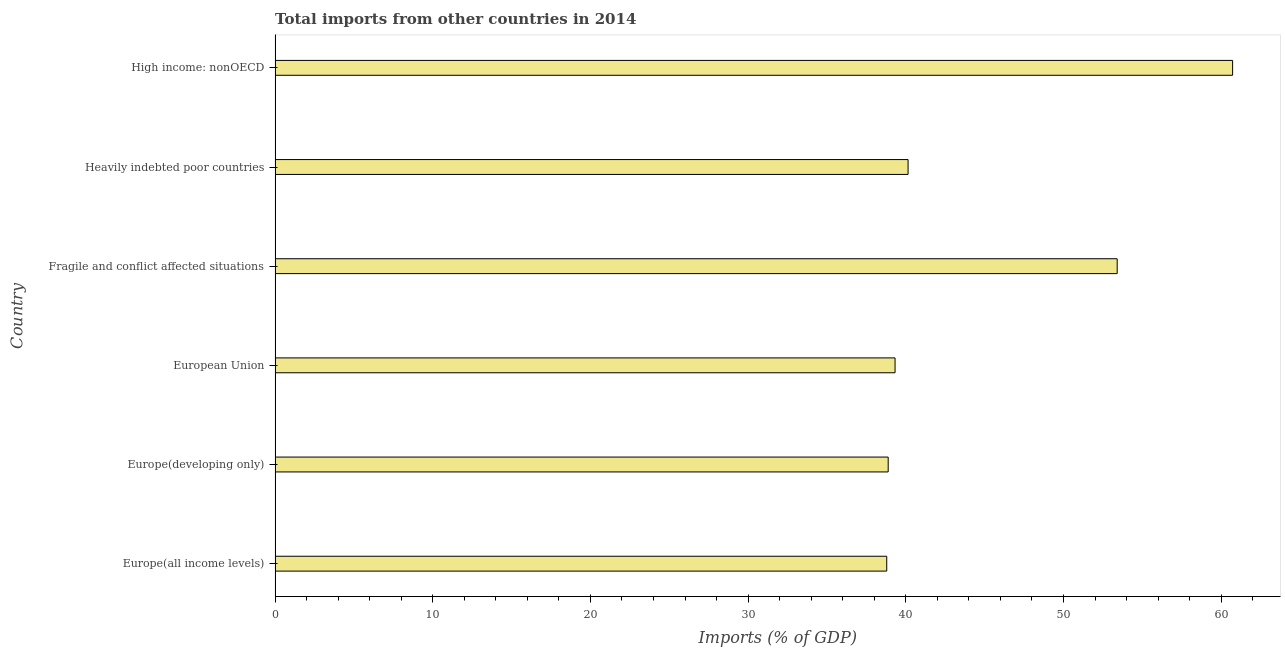Does the graph contain grids?
Offer a terse response. No. What is the title of the graph?
Ensure brevity in your answer.  Total imports from other countries in 2014. What is the label or title of the X-axis?
Provide a short and direct response. Imports (% of GDP). What is the label or title of the Y-axis?
Give a very brief answer. Country. What is the total imports in European Union?
Your response must be concise. 39.32. Across all countries, what is the maximum total imports?
Your answer should be compact. 60.73. Across all countries, what is the minimum total imports?
Give a very brief answer. 38.79. In which country was the total imports maximum?
Offer a very short reply. High income: nonOECD. In which country was the total imports minimum?
Your answer should be very brief. Europe(all income levels). What is the sum of the total imports?
Keep it short and to the point. 271.27. What is the difference between the total imports in Europe(developing only) and High income: nonOECD?
Give a very brief answer. -21.84. What is the average total imports per country?
Your response must be concise. 45.21. What is the median total imports?
Provide a succinct answer. 39.73. In how many countries, is the total imports greater than 16 %?
Keep it short and to the point. 6. Is the difference between the total imports in Europe(all income levels) and Fragile and conflict affected situations greater than the difference between any two countries?
Offer a very short reply. No. What is the difference between the highest and the second highest total imports?
Make the answer very short. 7.32. Is the sum of the total imports in Europe(developing only) and High income: nonOECD greater than the maximum total imports across all countries?
Keep it short and to the point. Yes. What is the difference between the highest and the lowest total imports?
Offer a very short reply. 21.94. In how many countries, is the total imports greater than the average total imports taken over all countries?
Your response must be concise. 2. How many bars are there?
Provide a succinct answer. 6. Are all the bars in the graph horizontal?
Your answer should be very brief. Yes. How many countries are there in the graph?
Make the answer very short. 6. What is the difference between two consecutive major ticks on the X-axis?
Ensure brevity in your answer.  10. What is the Imports (% of GDP) in Europe(all income levels)?
Give a very brief answer. 38.79. What is the Imports (% of GDP) of Europe(developing only)?
Your answer should be very brief. 38.88. What is the Imports (% of GDP) in European Union?
Ensure brevity in your answer.  39.32. What is the Imports (% of GDP) in Fragile and conflict affected situations?
Provide a succinct answer. 53.41. What is the Imports (% of GDP) of Heavily indebted poor countries?
Provide a short and direct response. 40.14. What is the Imports (% of GDP) in High income: nonOECD?
Keep it short and to the point. 60.73. What is the difference between the Imports (% of GDP) in Europe(all income levels) and Europe(developing only)?
Offer a terse response. -0.09. What is the difference between the Imports (% of GDP) in Europe(all income levels) and European Union?
Your response must be concise. -0.53. What is the difference between the Imports (% of GDP) in Europe(all income levels) and Fragile and conflict affected situations?
Provide a short and direct response. -14.62. What is the difference between the Imports (% of GDP) in Europe(all income levels) and Heavily indebted poor countries?
Offer a very short reply. -1.35. What is the difference between the Imports (% of GDP) in Europe(all income levels) and High income: nonOECD?
Give a very brief answer. -21.94. What is the difference between the Imports (% of GDP) in Europe(developing only) and European Union?
Offer a very short reply. -0.44. What is the difference between the Imports (% of GDP) in Europe(developing only) and Fragile and conflict affected situations?
Offer a terse response. -14.52. What is the difference between the Imports (% of GDP) in Europe(developing only) and Heavily indebted poor countries?
Your response must be concise. -1.26. What is the difference between the Imports (% of GDP) in Europe(developing only) and High income: nonOECD?
Your answer should be very brief. -21.84. What is the difference between the Imports (% of GDP) in European Union and Fragile and conflict affected situations?
Offer a terse response. -14.09. What is the difference between the Imports (% of GDP) in European Union and Heavily indebted poor countries?
Offer a very short reply. -0.83. What is the difference between the Imports (% of GDP) in European Union and High income: nonOECD?
Keep it short and to the point. -21.41. What is the difference between the Imports (% of GDP) in Fragile and conflict affected situations and Heavily indebted poor countries?
Offer a terse response. 13.26. What is the difference between the Imports (% of GDP) in Fragile and conflict affected situations and High income: nonOECD?
Keep it short and to the point. -7.32. What is the difference between the Imports (% of GDP) in Heavily indebted poor countries and High income: nonOECD?
Ensure brevity in your answer.  -20.58. What is the ratio of the Imports (% of GDP) in Europe(all income levels) to that in Europe(developing only)?
Provide a short and direct response. 1. What is the ratio of the Imports (% of GDP) in Europe(all income levels) to that in European Union?
Provide a succinct answer. 0.99. What is the ratio of the Imports (% of GDP) in Europe(all income levels) to that in Fragile and conflict affected situations?
Make the answer very short. 0.73. What is the ratio of the Imports (% of GDP) in Europe(all income levels) to that in Heavily indebted poor countries?
Your answer should be compact. 0.97. What is the ratio of the Imports (% of GDP) in Europe(all income levels) to that in High income: nonOECD?
Your response must be concise. 0.64. What is the ratio of the Imports (% of GDP) in Europe(developing only) to that in European Union?
Your answer should be compact. 0.99. What is the ratio of the Imports (% of GDP) in Europe(developing only) to that in Fragile and conflict affected situations?
Provide a succinct answer. 0.73. What is the ratio of the Imports (% of GDP) in Europe(developing only) to that in High income: nonOECD?
Ensure brevity in your answer.  0.64. What is the ratio of the Imports (% of GDP) in European Union to that in Fragile and conflict affected situations?
Provide a short and direct response. 0.74. What is the ratio of the Imports (% of GDP) in European Union to that in High income: nonOECD?
Keep it short and to the point. 0.65. What is the ratio of the Imports (% of GDP) in Fragile and conflict affected situations to that in Heavily indebted poor countries?
Give a very brief answer. 1.33. What is the ratio of the Imports (% of GDP) in Fragile and conflict affected situations to that in High income: nonOECD?
Give a very brief answer. 0.88. What is the ratio of the Imports (% of GDP) in Heavily indebted poor countries to that in High income: nonOECD?
Give a very brief answer. 0.66. 